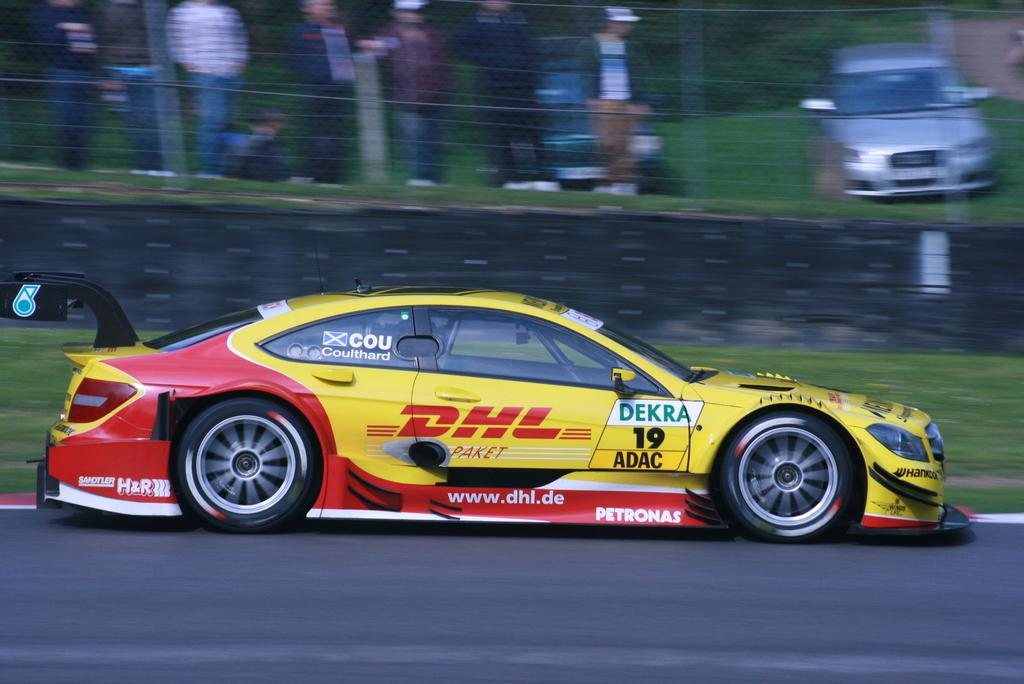What is the main subject of the image? There is a racing car on the road in the image. What can be seen in the background of the image? There are people standing near a fence and two cars parked on the ground in the background of the image. Can you see a snake with a long tail in the image? There is no snake or any other animal visible in the image. 